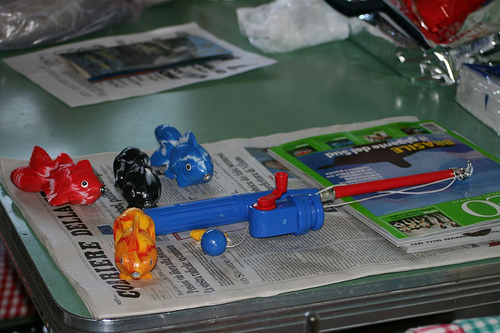<image>
Can you confirm if the fish is on the fishing line? No. The fish is not positioned on the fishing line. They may be near each other, but the fish is not supported by or resting on top of the fishing line. 